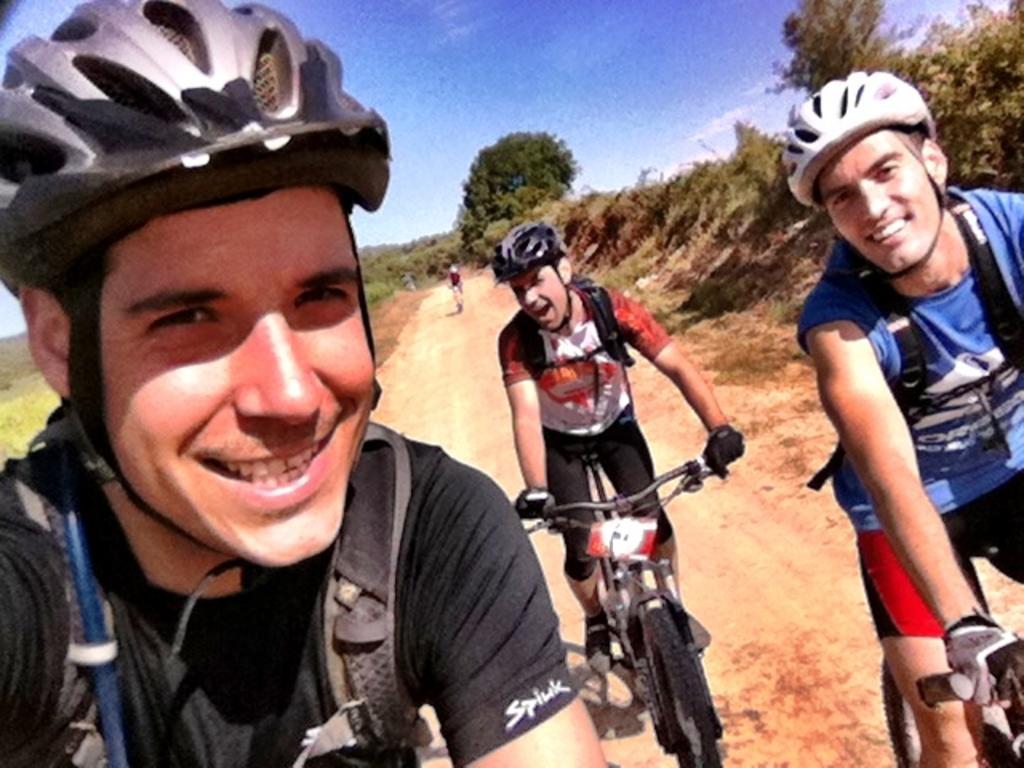Describe this image in one or two sentences. There are three persons wearing bags and helmets. On the right two persons are on cycle and wearing gloves. In the back there is road, trees and sky. 